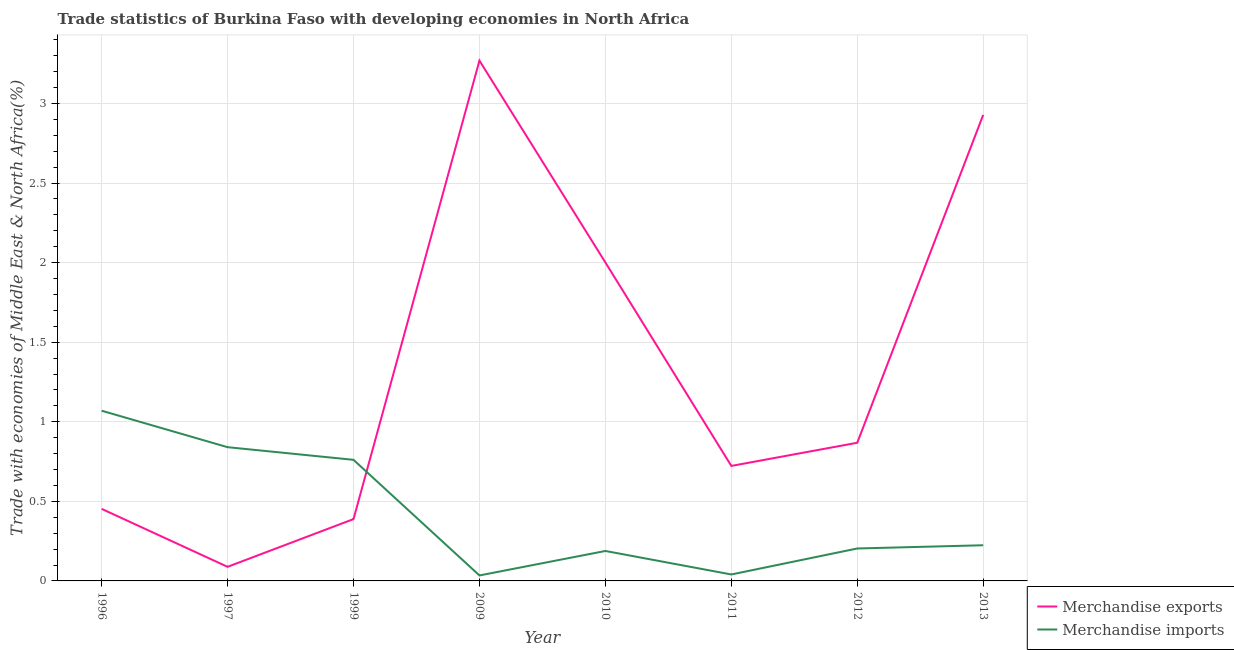Does the line corresponding to merchandise imports intersect with the line corresponding to merchandise exports?
Your response must be concise. Yes. What is the merchandise exports in 1999?
Your answer should be compact. 0.39. Across all years, what is the maximum merchandise exports?
Offer a terse response. 3.27. Across all years, what is the minimum merchandise exports?
Offer a very short reply. 0.09. In which year was the merchandise imports maximum?
Offer a terse response. 1996. What is the total merchandise imports in the graph?
Give a very brief answer. 3.36. What is the difference between the merchandise imports in 1996 and that in 2009?
Offer a terse response. 1.04. What is the difference between the merchandise exports in 2012 and the merchandise imports in 1997?
Ensure brevity in your answer.  0.03. What is the average merchandise imports per year?
Your answer should be compact. 0.42. In the year 2011, what is the difference between the merchandise exports and merchandise imports?
Provide a succinct answer. 0.68. What is the ratio of the merchandise exports in 2009 to that in 2013?
Offer a terse response. 1.12. Is the difference between the merchandise imports in 2010 and 2013 greater than the difference between the merchandise exports in 2010 and 2013?
Provide a short and direct response. Yes. What is the difference between the highest and the second highest merchandise exports?
Make the answer very short. 0.34. What is the difference between the highest and the lowest merchandise imports?
Give a very brief answer. 1.04. In how many years, is the merchandise exports greater than the average merchandise exports taken over all years?
Your answer should be very brief. 3. Does the merchandise exports monotonically increase over the years?
Provide a succinct answer. No. How many years are there in the graph?
Offer a very short reply. 8. What is the difference between two consecutive major ticks on the Y-axis?
Make the answer very short. 0.5. Does the graph contain any zero values?
Provide a succinct answer. No. Does the graph contain grids?
Keep it short and to the point. Yes. How many legend labels are there?
Your answer should be compact. 2. What is the title of the graph?
Ensure brevity in your answer.  Trade statistics of Burkina Faso with developing economies in North Africa. Does "Current US$" appear as one of the legend labels in the graph?
Make the answer very short. No. What is the label or title of the Y-axis?
Provide a short and direct response. Trade with economies of Middle East & North Africa(%). What is the Trade with economies of Middle East & North Africa(%) of Merchandise exports in 1996?
Your answer should be very brief. 0.45. What is the Trade with economies of Middle East & North Africa(%) of Merchandise imports in 1996?
Your response must be concise. 1.07. What is the Trade with economies of Middle East & North Africa(%) of Merchandise exports in 1997?
Your answer should be very brief. 0.09. What is the Trade with economies of Middle East & North Africa(%) of Merchandise imports in 1997?
Your answer should be compact. 0.84. What is the Trade with economies of Middle East & North Africa(%) of Merchandise exports in 1999?
Offer a very short reply. 0.39. What is the Trade with economies of Middle East & North Africa(%) in Merchandise imports in 1999?
Your response must be concise. 0.76. What is the Trade with economies of Middle East & North Africa(%) in Merchandise exports in 2009?
Keep it short and to the point. 3.27. What is the Trade with economies of Middle East & North Africa(%) of Merchandise imports in 2009?
Your answer should be very brief. 0.03. What is the Trade with economies of Middle East & North Africa(%) in Merchandise exports in 2010?
Offer a very short reply. 2. What is the Trade with economies of Middle East & North Africa(%) of Merchandise imports in 2010?
Provide a short and direct response. 0.19. What is the Trade with economies of Middle East & North Africa(%) of Merchandise exports in 2011?
Keep it short and to the point. 0.72. What is the Trade with economies of Middle East & North Africa(%) of Merchandise imports in 2011?
Offer a terse response. 0.04. What is the Trade with economies of Middle East & North Africa(%) in Merchandise exports in 2012?
Keep it short and to the point. 0.87. What is the Trade with economies of Middle East & North Africa(%) in Merchandise imports in 2012?
Provide a succinct answer. 0.2. What is the Trade with economies of Middle East & North Africa(%) in Merchandise exports in 2013?
Make the answer very short. 2.93. What is the Trade with economies of Middle East & North Africa(%) of Merchandise imports in 2013?
Make the answer very short. 0.22. Across all years, what is the maximum Trade with economies of Middle East & North Africa(%) in Merchandise exports?
Your answer should be compact. 3.27. Across all years, what is the maximum Trade with economies of Middle East & North Africa(%) of Merchandise imports?
Offer a terse response. 1.07. Across all years, what is the minimum Trade with economies of Middle East & North Africa(%) in Merchandise exports?
Provide a succinct answer. 0.09. Across all years, what is the minimum Trade with economies of Middle East & North Africa(%) in Merchandise imports?
Make the answer very short. 0.03. What is the total Trade with economies of Middle East & North Africa(%) in Merchandise exports in the graph?
Give a very brief answer. 10.72. What is the total Trade with economies of Middle East & North Africa(%) in Merchandise imports in the graph?
Offer a very short reply. 3.36. What is the difference between the Trade with economies of Middle East & North Africa(%) in Merchandise exports in 1996 and that in 1997?
Your answer should be compact. 0.36. What is the difference between the Trade with economies of Middle East & North Africa(%) of Merchandise imports in 1996 and that in 1997?
Provide a short and direct response. 0.23. What is the difference between the Trade with economies of Middle East & North Africa(%) of Merchandise exports in 1996 and that in 1999?
Your answer should be very brief. 0.06. What is the difference between the Trade with economies of Middle East & North Africa(%) in Merchandise imports in 1996 and that in 1999?
Give a very brief answer. 0.31. What is the difference between the Trade with economies of Middle East & North Africa(%) of Merchandise exports in 1996 and that in 2009?
Your answer should be compact. -2.82. What is the difference between the Trade with economies of Middle East & North Africa(%) in Merchandise imports in 1996 and that in 2009?
Your answer should be very brief. 1.04. What is the difference between the Trade with economies of Middle East & North Africa(%) of Merchandise exports in 1996 and that in 2010?
Make the answer very short. -1.55. What is the difference between the Trade with economies of Middle East & North Africa(%) in Merchandise imports in 1996 and that in 2010?
Provide a succinct answer. 0.88. What is the difference between the Trade with economies of Middle East & North Africa(%) of Merchandise exports in 1996 and that in 2011?
Make the answer very short. -0.27. What is the difference between the Trade with economies of Middle East & North Africa(%) of Merchandise exports in 1996 and that in 2012?
Offer a terse response. -0.42. What is the difference between the Trade with economies of Middle East & North Africa(%) of Merchandise imports in 1996 and that in 2012?
Provide a succinct answer. 0.87. What is the difference between the Trade with economies of Middle East & North Africa(%) of Merchandise exports in 1996 and that in 2013?
Your response must be concise. -2.48. What is the difference between the Trade with economies of Middle East & North Africa(%) of Merchandise imports in 1996 and that in 2013?
Provide a short and direct response. 0.85. What is the difference between the Trade with economies of Middle East & North Africa(%) of Merchandise imports in 1997 and that in 1999?
Ensure brevity in your answer.  0.08. What is the difference between the Trade with economies of Middle East & North Africa(%) in Merchandise exports in 1997 and that in 2009?
Provide a succinct answer. -3.18. What is the difference between the Trade with economies of Middle East & North Africa(%) in Merchandise imports in 1997 and that in 2009?
Make the answer very short. 0.81. What is the difference between the Trade with economies of Middle East & North Africa(%) of Merchandise exports in 1997 and that in 2010?
Offer a terse response. -1.91. What is the difference between the Trade with economies of Middle East & North Africa(%) of Merchandise imports in 1997 and that in 2010?
Ensure brevity in your answer.  0.65. What is the difference between the Trade with economies of Middle East & North Africa(%) in Merchandise exports in 1997 and that in 2011?
Provide a succinct answer. -0.63. What is the difference between the Trade with economies of Middle East & North Africa(%) of Merchandise imports in 1997 and that in 2011?
Make the answer very short. 0.8. What is the difference between the Trade with economies of Middle East & North Africa(%) of Merchandise exports in 1997 and that in 2012?
Make the answer very short. -0.78. What is the difference between the Trade with economies of Middle East & North Africa(%) in Merchandise imports in 1997 and that in 2012?
Your response must be concise. 0.64. What is the difference between the Trade with economies of Middle East & North Africa(%) in Merchandise exports in 1997 and that in 2013?
Provide a succinct answer. -2.84. What is the difference between the Trade with economies of Middle East & North Africa(%) in Merchandise imports in 1997 and that in 2013?
Ensure brevity in your answer.  0.62. What is the difference between the Trade with economies of Middle East & North Africa(%) in Merchandise exports in 1999 and that in 2009?
Give a very brief answer. -2.88. What is the difference between the Trade with economies of Middle East & North Africa(%) of Merchandise imports in 1999 and that in 2009?
Provide a succinct answer. 0.73. What is the difference between the Trade with economies of Middle East & North Africa(%) of Merchandise exports in 1999 and that in 2010?
Offer a very short reply. -1.61. What is the difference between the Trade with economies of Middle East & North Africa(%) in Merchandise imports in 1999 and that in 2010?
Your answer should be very brief. 0.57. What is the difference between the Trade with economies of Middle East & North Africa(%) in Merchandise exports in 1999 and that in 2011?
Offer a very short reply. -0.33. What is the difference between the Trade with economies of Middle East & North Africa(%) of Merchandise imports in 1999 and that in 2011?
Your response must be concise. 0.72. What is the difference between the Trade with economies of Middle East & North Africa(%) in Merchandise exports in 1999 and that in 2012?
Provide a succinct answer. -0.48. What is the difference between the Trade with economies of Middle East & North Africa(%) of Merchandise imports in 1999 and that in 2012?
Your response must be concise. 0.56. What is the difference between the Trade with economies of Middle East & North Africa(%) of Merchandise exports in 1999 and that in 2013?
Provide a short and direct response. -2.54. What is the difference between the Trade with economies of Middle East & North Africa(%) in Merchandise imports in 1999 and that in 2013?
Your response must be concise. 0.54. What is the difference between the Trade with economies of Middle East & North Africa(%) of Merchandise exports in 2009 and that in 2010?
Keep it short and to the point. 1.27. What is the difference between the Trade with economies of Middle East & North Africa(%) of Merchandise imports in 2009 and that in 2010?
Your response must be concise. -0.15. What is the difference between the Trade with economies of Middle East & North Africa(%) in Merchandise exports in 2009 and that in 2011?
Your answer should be very brief. 2.55. What is the difference between the Trade with economies of Middle East & North Africa(%) of Merchandise imports in 2009 and that in 2011?
Your answer should be compact. -0.01. What is the difference between the Trade with economies of Middle East & North Africa(%) of Merchandise exports in 2009 and that in 2012?
Offer a very short reply. 2.4. What is the difference between the Trade with economies of Middle East & North Africa(%) of Merchandise imports in 2009 and that in 2012?
Give a very brief answer. -0.17. What is the difference between the Trade with economies of Middle East & North Africa(%) in Merchandise exports in 2009 and that in 2013?
Your response must be concise. 0.34. What is the difference between the Trade with economies of Middle East & North Africa(%) in Merchandise imports in 2009 and that in 2013?
Provide a succinct answer. -0.19. What is the difference between the Trade with economies of Middle East & North Africa(%) of Merchandise exports in 2010 and that in 2011?
Offer a terse response. 1.28. What is the difference between the Trade with economies of Middle East & North Africa(%) in Merchandise imports in 2010 and that in 2011?
Provide a succinct answer. 0.15. What is the difference between the Trade with economies of Middle East & North Africa(%) of Merchandise exports in 2010 and that in 2012?
Keep it short and to the point. 1.13. What is the difference between the Trade with economies of Middle East & North Africa(%) of Merchandise imports in 2010 and that in 2012?
Ensure brevity in your answer.  -0.02. What is the difference between the Trade with economies of Middle East & North Africa(%) in Merchandise exports in 2010 and that in 2013?
Your answer should be very brief. -0.93. What is the difference between the Trade with economies of Middle East & North Africa(%) of Merchandise imports in 2010 and that in 2013?
Your answer should be compact. -0.04. What is the difference between the Trade with economies of Middle East & North Africa(%) in Merchandise exports in 2011 and that in 2012?
Make the answer very short. -0.15. What is the difference between the Trade with economies of Middle East & North Africa(%) of Merchandise imports in 2011 and that in 2012?
Give a very brief answer. -0.16. What is the difference between the Trade with economies of Middle East & North Africa(%) of Merchandise exports in 2011 and that in 2013?
Provide a succinct answer. -2.21. What is the difference between the Trade with economies of Middle East & North Africa(%) of Merchandise imports in 2011 and that in 2013?
Ensure brevity in your answer.  -0.18. What is the difference between the Trade with economies of Middle East & North Africa(%) in Merchandise exports in 2012 and that in 2013?
Give a very brief answer. -2.06. What is the difference between the Trade with economies of Middle East & North Africa(%) in Merchandise imports in 2012 and that in 2013?
Your response must be concise. -0.02. What is the difference between the Trade with economies of Middle East & North Africa(%) in Merchandise exports in 1996 and the Trade with economies of Middle East & North Africa(%) in Merchandise imports in 1997?
Provide a short and direct response. -0.39. What is the difference between the Trade with economies of Middle East & North Africa(%) of Merchandise exports in 1996 and the Trade with economies of Middle East & North Africa(%) of Merchandise imports in 1999?
Ensure brevity in your answer.  -0.31. What is the difference between the Trade with economies of Middle East & North Africa(%) of Merchandise exports in 1996 and the Trade with economies of Middle East & North Africa(%) of Merchandise imports in 2009?
Provide a short and direct response. 0.42. What is the difference between the Trade with economies of Middle East & North Africa(%) of Merchandise exports in 1996 and the Trade with economies of Middle East & North Africa(%) of Merchandise imports in 2010?
Keep it short and to the point. 0.26. What is the difference between the Trade with economies of Middle East & North Africa(%) of Merchandise exports in 1996 and the Trade with economies of Middle East & North Africa(%) of Merchandise imports in 2011?
Offer a terse response. 0.41. What is the difference between the Trade with economies of Middle East & North Africa(%) of Merchandise exports in 1996 and the Trade with economies of Middle East & North Africa(%) of Merchandise imports in 2012?
Give a very brief answer. 0.25. What is the difference between the Trade with economies of Middle East & North Africa(%) in Merchandise exports in 1996 and the Trade with economies of Middle East & North Africa(%) in Merchandise imports in 2013?
Your response must be concise. 0.23. What is the difference between the Trade with economies of Middle East & North Africa(%) in Merchandise exports in 1997 and the Trade with economies of Middle East & North Africa(%) in Merchandise imports in 1999?
Offer a very short reply. -0.67. What is the difference between the Trade with economies of Middle East & North Africa(%) in Merchandise exports in 1997 and the Trade with economies of Middle East & North Africa(%) in Merchandise imports in 2009?
Provide a short and direct response. 0.05. What is the difference between the Trade with economies of Middle East & North Africa(%) in Merchandise exports in 1997 and the Trade with economies of Middle East & North Africa(%) in Merchandise imports in 2010?
Your response must be concise. -0.1. What is the difference between the Trade with economies of Middle East & North Africa(%) of Merchandise exports in 1997 and the Trade with economies of Middle East & North Africa(%) of Merchandise imports in 2011?
Provide a succinct answer. 0.05. What is the difference between the Trade with economies of Middle East & North Africa(%) of Merchandise exports in 1997 and the Trade with economies of Middle East & North Africa(%) of Merchandise imports in 2012?
Offer a very short reply. -0.12. What is the difference between the Trade with economies of Middle East & North Africa(%) in Merchandise exports in 1997 and the Trade with economies of Middle East & North Africa(%) in Merchandise imports in 2013?
Your answer should be compact. -0.14. What is the difference between the Trade with economies of Middle East & North Africa(%) of Merchandise exports in 1999 and the Trade with economies of Middle East & North Africa(%) of Merchandise imports in 2009?
Keep it short and to the point. 0.35. What is the difference between the Trade with economies of Middle East & North Africa(%) in Merchandise exports in 1999 and the Trade with economies of Middle East & North Africa(%) in Merchandise imports in 2010?
Offer a terse response. 0.2. What is the difference between the Trade with economies of Middle East & North Africa(%) in Merchandise exports in 1999 and the Trade with economies of Middle East & North Africa(%) in Merchandise imports in 2011?
Make the answer very short. 0.35. What is the difference between the Trade with economies of Middle East & North Africa(%) in Merchandise exports in 1999 and the Trade with economies of Middle East & North Africa(%) in Merchandise imports in 2012?
Provide a succinct answer. 0.18. What is the difference between the Trade with economies of Middle East & North Africa(%) of Merchandise exports in 1999 and the Trade with economies of Middle East & North Africa(%) of Merchandise imports in 2013?
Ensure brevity in your answer.  0.16. What is the difference between the Trade with economies of Middle East & North Africa(%) of Merchandise exports in 2009 and the Trade with economies of Middle East & North Africa(%) of Merchandise imports in 2010?
Offer a very short reply. 3.08. What is the difference between the Trade with economies of Middle East & North Africa(%) in Merchandise exports in 2009 and the Trade with economies of Middle East & North Africa(%) in Merchandise imports in 2011?
Your answer should be very brief. 3.23. What is the difference between the Trade with economies of Middle East & North Africa(%) in Merchandise exports in 2009 and the Trade with economies of Middle East & North Africa(%) in Merchandise imports in 2012?
Your answer should be compact. 3.07. What is the difference between the Trade with economies of Middle East & North Africa(%) of Merchandise exports in 2009 and the Trade with economies of Middle East & North Africa(%) of Merchandise imports in 2013?
Offer a very short reply. 3.05. What is the difference between the Trade with economies of Middle East & North Africa(%) in Merchandise exports in 2010 and the Trade with economies of Middle East & North Africa(%) in Merchandise imports in 2011?
Make the answer very short. 1.96. What is the difference between the Trade with economies of Middle East & North Africa(%) in Merchandise exports in 2010 and the Trade with economies of Middle East & North Africa(%) in Merchandise imports in 2012?
Provide a short and direct response. 1.8. What is the difference between the Trade with economies of Middle East & North Africa(%) in Merchandise exports in 2010 and the Trade with economies of Middle East & North Africa(%) in Merchandise imports in 2013?
Provide a short and direct response. 1.78. What is the difference between the Trade with economies of Middle East & North Africa(%) of Merchandise exports in 2011 and the Trade with economies of Middle East & North Africa(%) of Merchandise imports in 2012?
Make the answer very short. 0.52. What is the difference between the Trade with economies of Middle East & North Africa(%) of Merchandise exports in 2011 and the Trade with economies of Middle East & North Africa(%) of Merchandise imports in 2013?
Make the answer very short. 0.5. What is the difference between the Trade with economies of Middle East & North Africa(%) in Merchandise exports in 2012 and the Trade with economies of Middle East & North Africa(%) in Merchandise imports in 2013?
Your answer should be very brief. 0.64. What is the average Trade with economies of Middle East & North Africa(%) in Merchandise exports per year?
Make the answer very short. 1.34. What is the average Trade with economies of Middle East & North Africa(%) in Merchandise imports per year?
Keep it short and to the point. 0.42. In the year 1996, what is the difference between the Trade with economies of Middle East & North Africa(%) of Merchandise exports and Trade with economies of Middle East & North Africa(%) of Merchandise imports?
Ensure brevity in your answer.  -0.62. In the year 1997, what is the difference between the Trade with economies of Middle East & North Africa(%) of Merchandise exports and Trade with economies of Middle East & North Africa(%) of Merchandise imports?
Keep it short and to the point. -0.75. In the year 1999, what is the difference between the Trade with economies of Middle East & North Africa(%) in Merchandise exports and Trade with economies of Middle East & North Africa(%) in Merchandise imports?
Offer a very short reply. -0.37. In the year 2009, what is the difference between the Trade with economies of Middle East & North Africa(%) of Merchandise exports and Trade with economies of Middle East & North Africa(%) of Merchandise imports?
Ensure brevity in your answer.  3.23. In the year 2010, what is the difference between the Trade with economies of Middle East & North Africa(%) in Merchandise exports and Trade with economies of Middle East & North Africa(%) in Merchandise imports?
Your answer should be very brief. 1.81. In the year 2011, what is the difference between the Trade with economies of Middle East & North Africa(%) of Merchandise exports and Trade with economies of Middle East & North Africa(%) of Merchandise imports?
Make the answer very short. 0.68. In the year 2012, what is the difference between the Trade with economies of Middle East & North Africa(%) of Merchandise exports and Trade with economies of Middle East & North Africa(%) of Merchandise imports?
Make the answer very short. 0.66. In the year 2013, what is the difference between the Trade with economies of Middle East & North Africa(%) in Merchandise exports and Trade with economies of Middle East & North Africa(%) in Merchandise imports?
Give a very brief answer. 2.7. What is the ratio of the Trade with economies of Middle East & North Africa(%) of Merchandise exports in 1996 to that in 1997?
Your response must be concise. 5.11. What is the ratio of the Trade with economies of Middle East & North Africa(%) in Merchandise imports in 1996 to that in 1997?
Ensure brevity in your answer.  1.27. What is the ratio of the Trade with economies of Middle East & North Africa(%) of Merchandise exports in 1996 to that in 1999?
Your answer should be very brief. 1.17. What is the ratio of the Trade with economies of Middle East & North Africa(%) in Merchandise imports in 1996 to that in 1999?
Make the answer very short. 1.41. What is the ratio of the Trade with economies of Middle East & North Africa(%) in Merchandise exports in 1996 to that in 2009?
Offer a terse response. 0.14. What is the ratio of the Trade with economies of Middle East & North Africa(%) in Merchandise imports in 1996 to that in 2009?
Offer a very short reply. 31.08. What is the ratio of the Trade with economies of Middle East & North Africa(%) in Merchandise exports in 1996 to that in 2010?
Make the answer very short. 0.23. What is the ratio of the Trade with economies of Middle East & North Africa(%) of Merchandise imports in 1996 to that in 2010?
Give a very brief answer. 5.68. What is the ratio of the Trade with economies of Middle East & North Africa(%) in Merchandise exports in 1996 to that in 2011?
Provide a short and direct response. 0.63. What is the ratio of the Trade with economies of Middle East & North Africa(%) in Merchandise imports in 1996 to that in 2011?
Your answer should be compact. 26.37. What is the ratio of the Trade with economies of Middle East & North Africa(%) in Merchandise exports in 1996 to that in 2012?
Offer a very short reply. 0.52. What is the ratio of the Trade with economies of Middle East & North Africa(%) in Merchandise imports in 1996 to that in 2012?
Your response must be concise. 5.25. What is the ratio of the Trade with economies of Middle East & North Africa(%) in Merchandise exports in 1996 to that in 2013?
Make the answer very short. 0.15. What is the ratio of the Trade with economies of Middle East & North Africa(%) of Merchandise imports in 1996 to that in 2013?
Provide a succinct answer. 4.77. What is the ratio of the Trade with economies of Middle East & North Africa(%) of Merchandise exports in 1997 to that in 1999?
Your response must be concise. 0.23. What is the ratio of the Trade with economies of Middle East & North Africa(%) of Merchandise imports in 1997 to that in 1999?
Provide a succinct answer. 1.1. What is the ratio of the Trade with economies of Middle East & North Africa(%) in Merchandise exports in 1997 to that in 2009?
Provide a succinct answer. 0.03. What is the ratio of the Trade with economies of Middle East & North Africa(%) in Merchandise imports in 1997 to that in 2009?
Your answer should be very brief. 24.42. What is the ratio of the Trade with economies of Middle East & North Africa(%) of Merchandise exports in 1997 to that in 2010?
Your answer should be compact. 0.04. What is the ratio of the Trade with economies of Middle East & North Africa(%) of Merchandise imports in 1997 to that in 2010?
Offer a very short reply. 4.47. What is the ratio of the Trade with economies of Middle East & North Africa(%) in Merchandise exports in 1997 to that in 2011?
Ensure brevity in your answer.  0.12. What is the ratio of the Trade with economies of Middle East & North Africa(%) of Merchandise imports in 1997 to that in 2011?
Offer a very short reply. 20.72. What is the ratio of the Trade with economies of Middle East & North Africa(%) of Merchandise exports in 1997 to that in 2012?
Make the answer very short. 0.1. What is the ratio of the Trade with economies of Middle East & North Africa(%) of Merchandise imports in 1997 to that in 2012?
Your response must be concise. 4.12. What is the ratio of the Trade with economies of Middle East & North Africa(%) of Merchandise exports in 1997 to that in 2013?
Your answer should be compact. 0.03. What is the ratio of the Trade with economies of Middle East & North Africa(%) in Merchandise imports in 1997 to that in 2013?
Provide a short and direct response. 3.75. What is the ratio of the Trade with economies of Middle East & North Africa(%) of Merchandise exports in 1999 to that in 2009?
Give a very brief answer. 0.12. What is the ratio of the Trade with economies of Middle East & North Africa(%) of Merchandise imports in 1999 to that in 2009?
Offer a very short reply. 22.11. What is the ratio of the Trade with economies of Middle East & North Africa(%) in Merchandise exports in 1999 to that in 2010?
Give a very brief answer. 0.19. What is the ratio of the Trade with economies of Middle East & North Africa(%) of Merchandise imports in 1999 to that in 2010?
Your response must be concise. 4.04. What is the ratio of the Trade with economies of Middle East & North Africa(%) in Merchandise exports in 1999 to that in 2011?
Ensure brevity in your answer.  0.54. What is the ratio of the Trade with economies of Middle East & North Africa(%) in Merchandise imports in 1999 to that in 2011?
Keep it short and to the point. 18.76. What is the ratio of the Trade with economies of Middle East & North Africa(%) of Merchandise exports in 1999 to that in 2012?
Your answer should be compact. 0.45. What is the ratio of the Trade with economies of Middle East & North Africa(%) of Merchandise imports in 1999 to that in 2012?
Make the answer very short. 3.73. What is the ratio of the Trade with economies of Middle East & North Africa(%) of Merchandise exports in 1999 to that in 2013?
Keep it short and to the point. 0.13. What is the ratio of the Trade with economies of Middle East & North Africa(%) of Merchandise imports in 1999 to that in 2013?
Your answer should be compact. 3.4. What is the ratio of the Trade with economies of Middle East & North Africa(%) in Merchandise exports in 2009 to that in 2010?
Your answer should be very brief. 1.63. What is the ratio of the Trade with economies of Middle East & North Africa(%) in Merchandise imports in 2009 to that in 2010?
Your answer should be very brief. 0.18. What is the ratio of the Trade with economies of Middle East & North Africa(%) of Merchandise exports in 2009 to that in 2011?
Make the answer very short. 4.52. What is the ratio of the Trade with economies of Middle East & North Africa(%) in Merchandise imports in 2009 to that in 2011?
Offer a terse response. 0.85. What is the ratio of the Trade with economies of Middle East & North Africa(%) of Merchandise exports in 2009 to that in 2012?
Offer a very short reply. 3.77. What is the ratio of the Trade with economies of Middle East & North Africa(%) of Merchandise imports in 2009 to that in 2012?
Give a very brief answer. 0.17. What is the ratio of the Trade with economies of Middle East & North Africa(%) of Merchandise exports in 2009 to that in 2013?
Your answer should be very brief. 1.12. What is the ratio of the Trade with economies of Middle East & North Africa(%) of Merchandise imports in 2009 to that in 2013?
Keep it short and to the point. 0.15. What is the ratio of the Trade with economies of Middle East & North Africa(%) in Merchandise exports in 2010 to that in 2011?
Give a very brief answer. 2.77. What is the ratio of the Trade with economies of Middle East & North Africa(%) in Merchandise imports in 2010 to that in 2011?
Make the answer very short. 4.64. What is the ratio of the Trade with economies of Middle East & North Africa(%) in Merchandise exports in 2010 to that in 2012?
Offer a very short reply. 2.31. What is the ratio of the Trade with economies of Middle East & North Africa(%) in Merchandise imports in 2010 to that in 2012?
Offer a terse response. 0.92. What is the ratio of the Trade with economies of Middle East & North Africa(%) of Merchandise exports in 2010 to that in 2013?
Give a very brief answer. 0.68. What is the ratio of the Trade with economies of Middle East & North Africa(%) of Merchandise imports in 2010 to that in 2013?
Offer a terse response. 0.84. What is the ratio of the Trade with economies of Middle East & North Africa(%) of Merchandise exports in 2011 to that in 2012?
Offer a terse response. 0.83. What is the ratio of the Trade with economies of Middle East & North Africa(%) in Merchandise imports in 2011 to that in 2012?
Provide a succinct answer. 0.2. What is the ratio of the Trade with economies of Middle East & North Africa(%) in Merchandise exports in 2011 to that in 2013?
Your answer should be very brief. 0.25. What is the ratio of the Trade with economies of Middle East & North Africa(%) of Merchandise imports in 2011 to that in 2013?
Your response must be concise. 0.18. What is the ratio of the Trade with economies of Middle East & North Africa(%) in Merchandise exports in 2012 to that in 2013?
Offer a very short reply. 0.3. What is the ratio of the Trade with economies of Middle East & North Africa(%) of Merchandise imports in 2012 to that in 2013?
Offer a very short reply. 0.91. What is the difference between the highest and the second highest Trade with economies of Middle East & North Africa(%) of Merchandise exports?
Make the answer very short. 0.34. What is the difference between the highest and the second highest Trade with economies of Middle East & North Africa(%) of Merchandise imports?
Your answer should be compact. 0.23. What is the difference between the highest and the lowest Trade with economies of Middle East & North Africa(%) of Merchandise exports?
Offer a very short reply. 3.18. What is the difference between the highest and the lowest Trade with economies of Middle East & North Africa(%) in Merchandise imports?
Your answer should be compact. 1.04. 